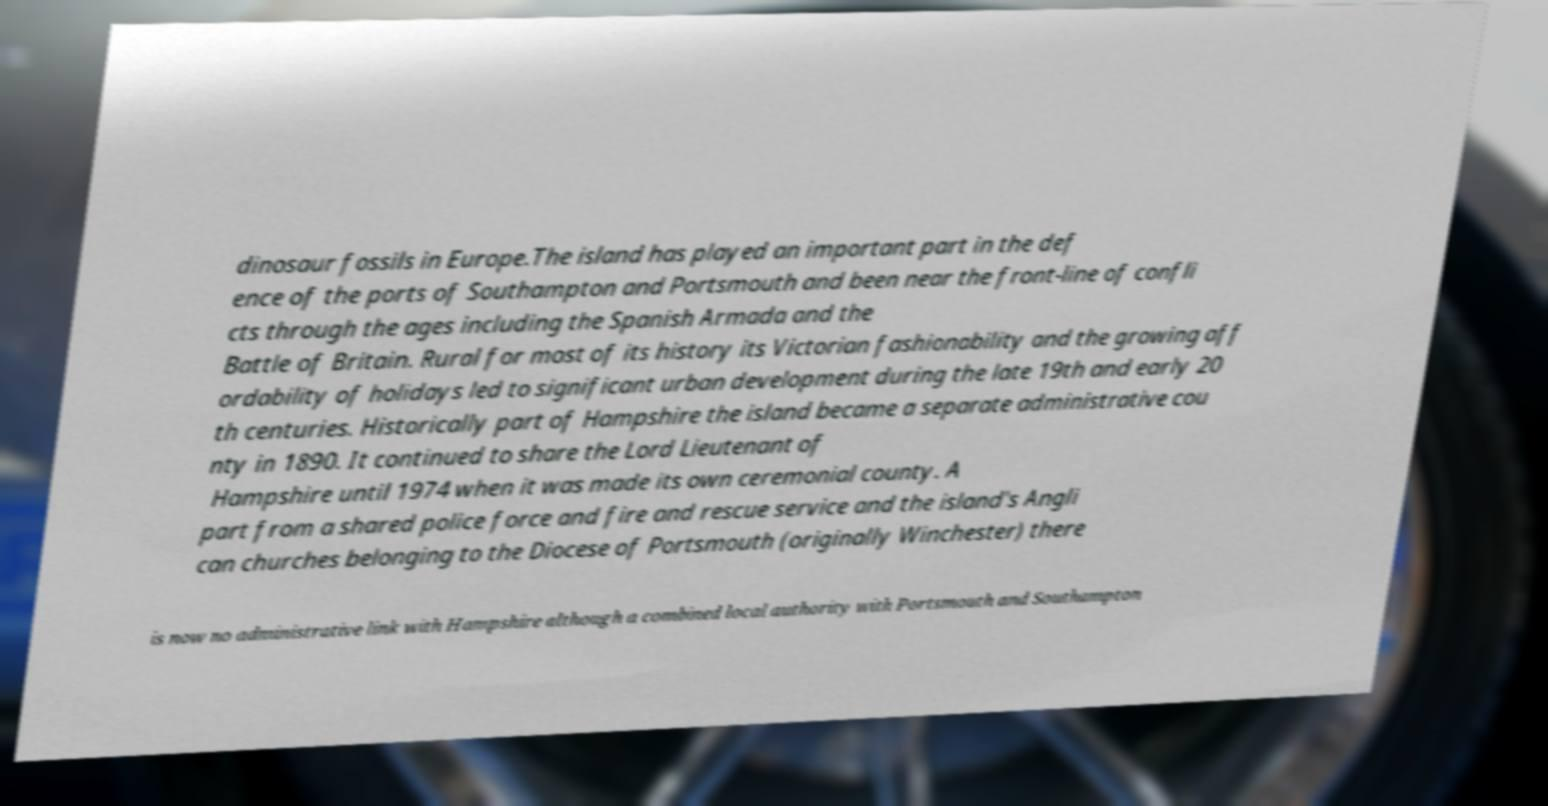I need the written content from this picture converted into text. Can you do that? dinosaur fossils in Europe.The island has played an important part in the def ence of the ports of Southampton and Portsmouth and been near the front-line of confli cts through the ages including the Spanish Armada and the Battle of Britain. Rural for most of its history its Victorian fashionability and the growing aff ordability of holidays led to significant urban development during the late 19th and early 20 th centuries. Historically part of Hampshire the island became a separate administrative cou nty in 1890. It continued to share the Lord Lieutenant of Hampshire until 1974 when it was made its own ceremonial county. A part from a shared police force and fire and rescue service and the island's Angli can churches belonging to the Diocese of Portsmouth (originally Winchester) there is now no administrative link with Hampshire although a combined local authority with Portsmouth and Southampton 